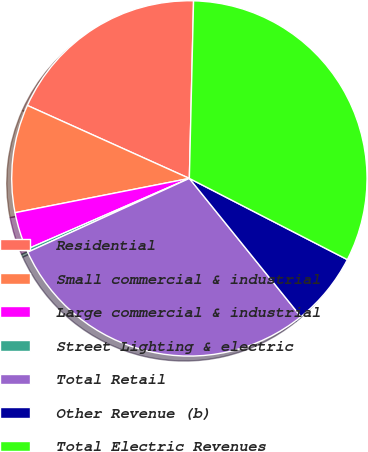Convert chart. <chart><loc_0><loc_0><loc_500><loc_500><pie_chart><fcel>Residential<fcel>Small commercial & industrial<fcel>Large commercial & industrial<fcel>Street Lighting & electric<fcel>Total Retail<fcel>Other Revenue (b)<fcel>Total Electric Revenues<nl><fcel>18.64%<fcel>9.83%<fcel>3.45%<fcel>0.27%<fcel>28.99%<fcel>6.64%<fcel>32.18%<nl></chart> 